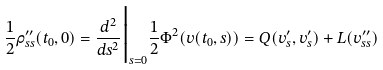<formula> <loc_0><loc_0><loc_500><loc_500>\frac { 1 } { 2 } \rho ^ { \prime \prime } _ { s s } ( t _ { 0 } , 0 ) = \frac { d ^ { 2 } } { d s ^ { 2 } } \Big | _ { s = 0 } \frac { 1 } { 2 } \Phi ^ { 2 } ( v ( t _ { 0 } , s ) ) = Q ( v ^ { \prime } _ { s } , v ^ { \prime } _ { s } ) + L ( v ^ { \prime \prime } _ { s s } )</formula> 